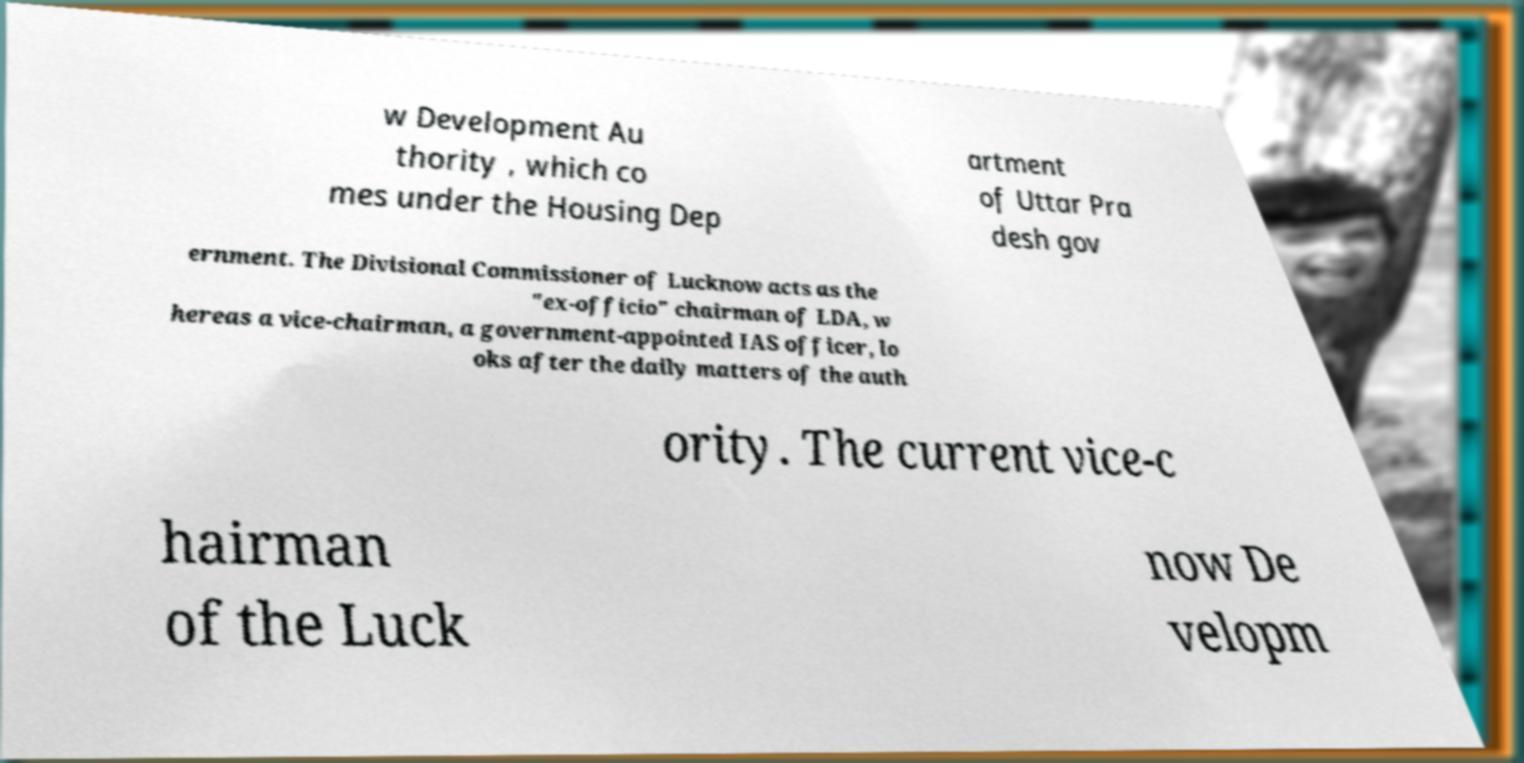Please identify and transcribe the text found in this image. w Development Au thority , which co mes under the Housing Dep artment of Uttar Pra desh gov ernment. The Divisional Commissioner of Lucknow acts as the "ex-officio" chairman of LDA, w hereas a vice-chairman, a government-appointed IAS officer, lo oks after the daily matters of the auth ority. The current vice-c hairman of the Luck now De velopm 